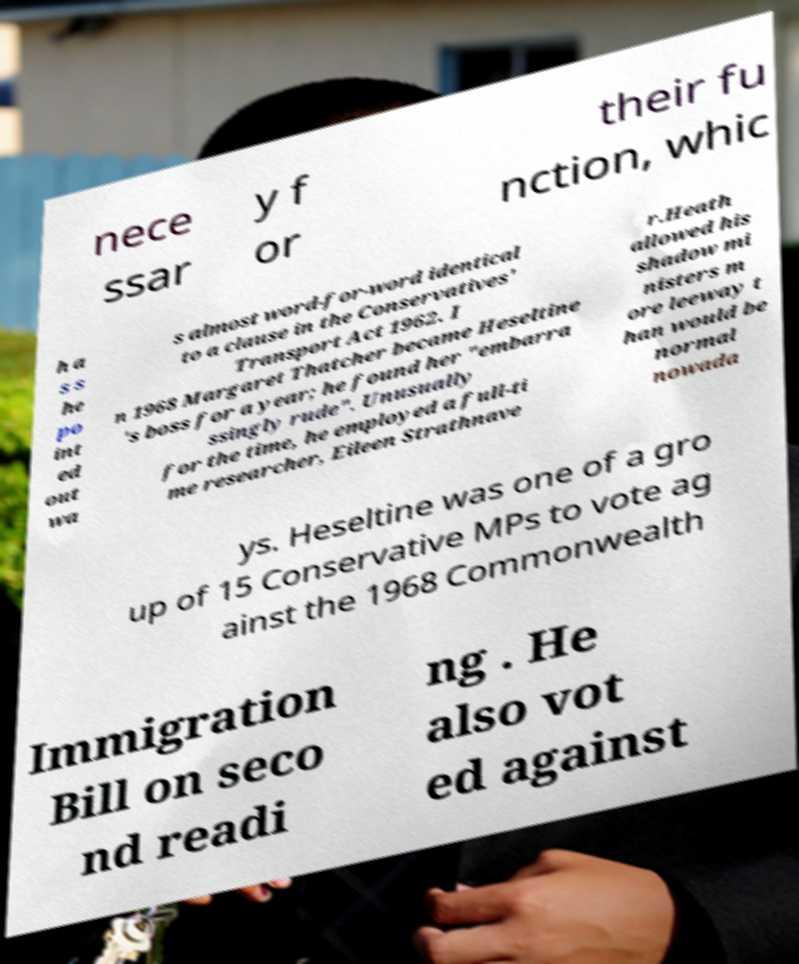Can you accurately transcribe the text from the provided image for me? nece ssar y f or their fu nction, whic h a s s he po int ed out wa s almost word-for-word identical to a clause in the Conservatives' Transport Act 1962. I n 1968 Margaret Thatcher became Heseltine 's boss for a year; he found her "embarra ssingly rude". Unusually for the time, he employed a full-ti me researcher, Eileen Strathnave r.Heath allowed his shadow mi nisters m ore leeway t han would be normal nowada ys. Heseltine was one of a gro up of 15 Conservative MPs to vote ag ainst the 1968 Commonwealth Immigration Bill on seco nd readi ng . He also vot ed against 